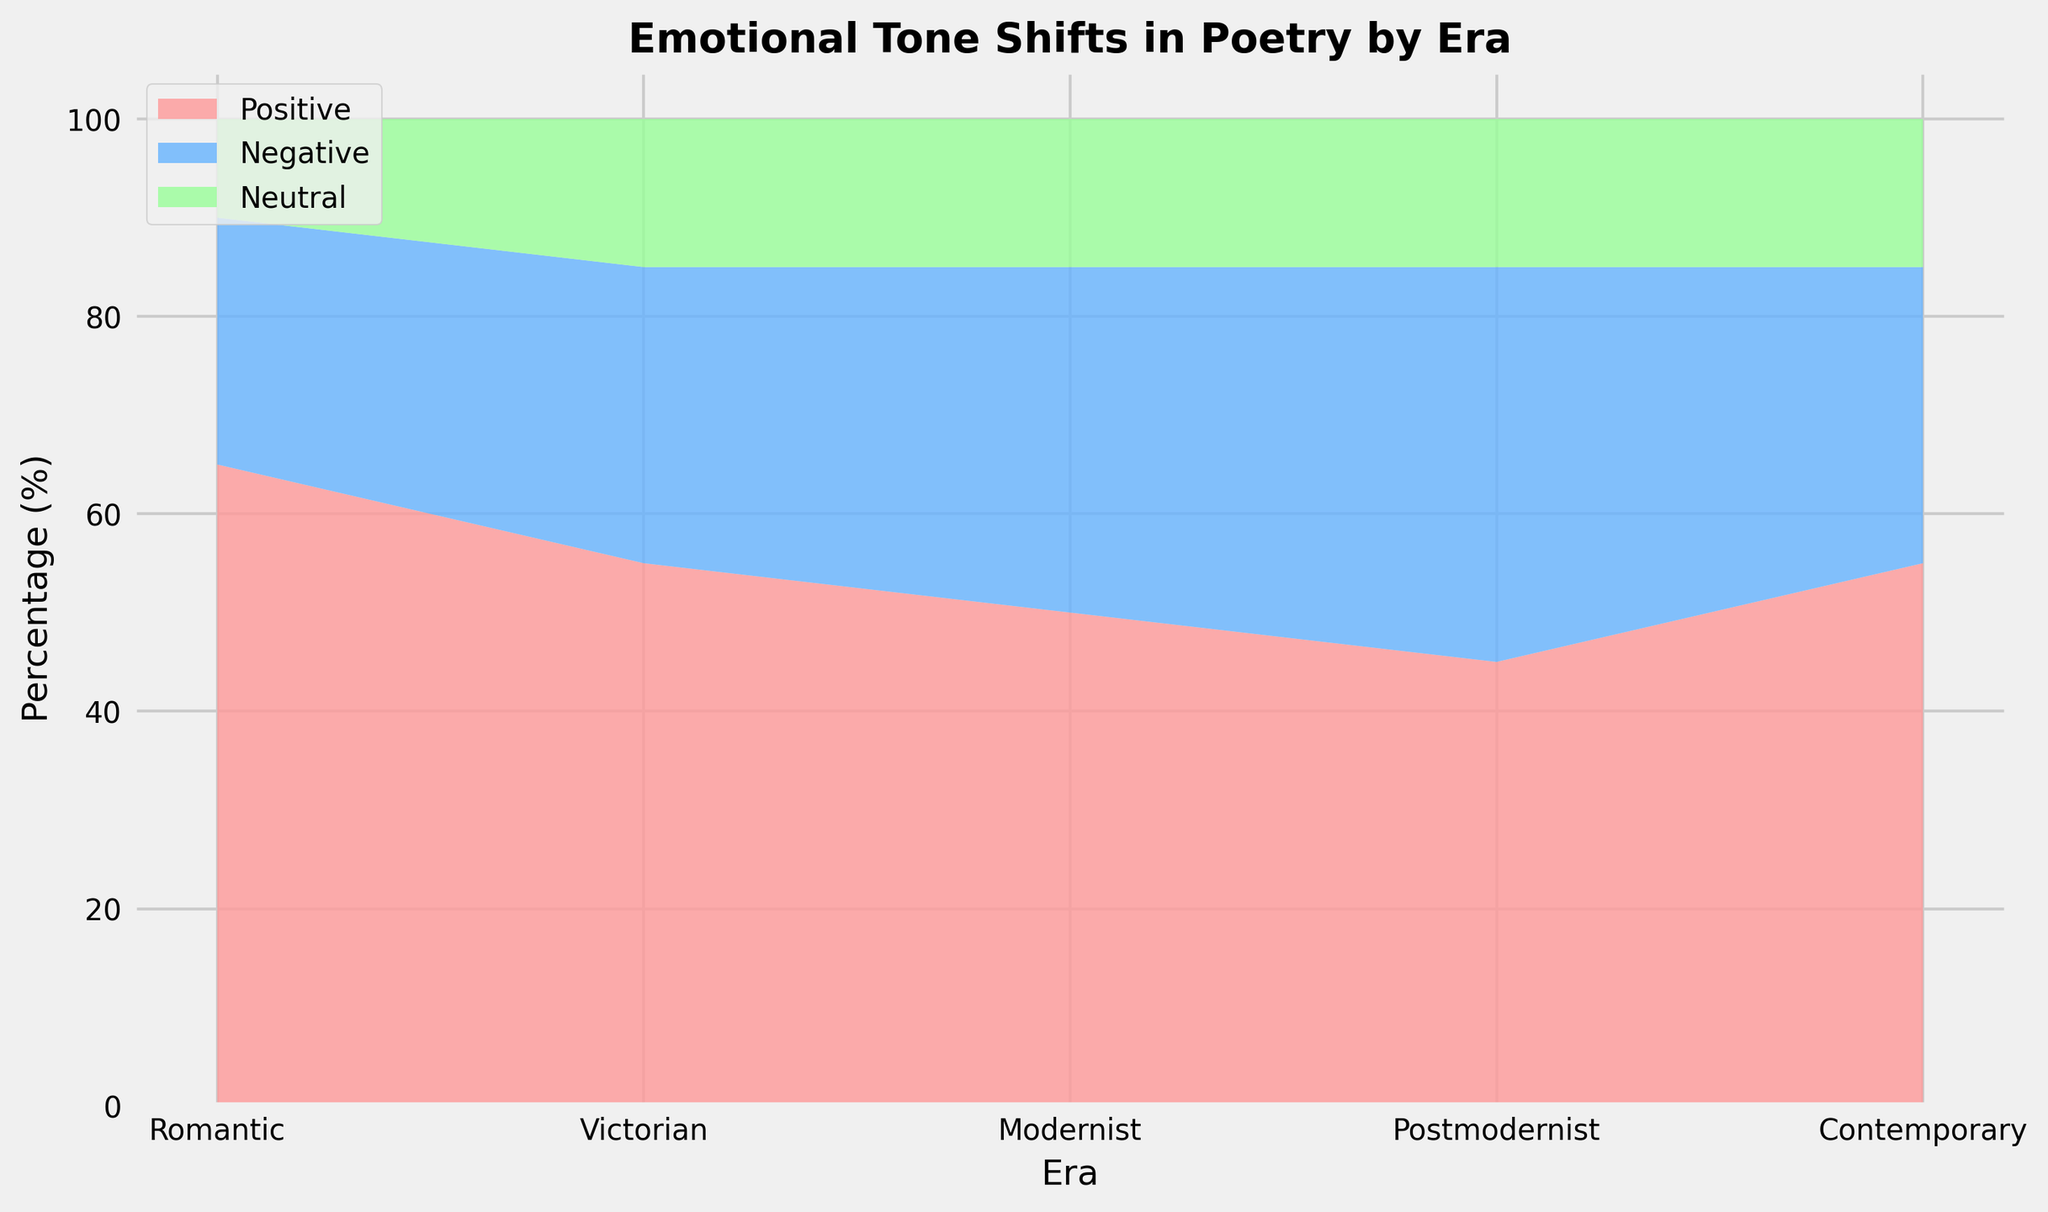What are the proportions of positive, negative, and neutral tones in the Victorian era? The Victorian era in the figure shows three areas: red for positive, blue for negative, and green for neutral. The proportions are given as 55% positive, 30% negative, and 15% neutral.
Answer: Positive: 55%, Negative: 30%, Neutral: 15% Which era shows the highest proportion of negative tones? The figure indicates different proportions of tones for each era. The Postmodernist era's negative tone area is the largest, indicating that it has the highest proportion at 40%.
Answer: Postmodernist How do the proportions of neutral tones change from the Romantic to the Modernist era? From the Romantic era to the Modernist era, the neutral tone proportion starts at 10%, increases to 15% in the Victorian era, and remains at 15% in the Modernist era. There is an increase from 10% to 15% between Romantic and Victorian eras but remains consistent from Victorian to Modernist.
Answer: Increased from 10% to 15%, then remained at 15% Compare the proportions of positive tones in the Romantic and Contemporary eras. Which one is higher and by how much? The figure shows that the Romantic era has 65% positive tones while the Contemporary era has 55%. The Romantic era thus has a higher proportion of positive tones by 10%.
Answer: Romantic by 10% How does the total proportion of non-neutral tones in the Contemporary era compare to that in the Victorian era? Adding the proportions of positive and negative tones: Victorian era has 55% positive + 30% negative = 85%, and the Contemporary era has 55% positive + 30% negative = 85%. Therefore, the total proportions are equal.
Answer: Equal, both are 85% Which era has the smallest variation in the proportions of emotional tones? The Victorian, Modernist, Postmodernist, and Contemporary eras all exhibit similar variation in emotional tones, with differences not exceeding 25%. The Romantic era shows a more significant variation, especially with a 65% positive tone. Therefore, the smallest variation is found in the eras other than Romantic. Inspecting visually, the eras besides Romantic exhibit this, but a closer look at percentages confirms Victorian is one of those.
Answer: Victorian, Modernist, Postmodernist, Contemporary all have smallest variations; detailed indication shows Victorian and others close Calculate the average proportion of positive tones across all eras. The proportions of positive tones are 65%, 55%, 50%, 45%, and 55%. Summing them up: 65 + 55 + 50 + 45 + 55 = 270. Dividing by 5 eras gives the average: 270 / 5 = 54%.
Answer: 54% Which era experienced the greatest drop in positive tones compared to its predecessor? The figure shows a drop in positive tones between eras. From Romantic (65%) to Victorian (55%) is a 10% drop. From Victorian (55%) to Modernist (50%) is a 5% drop. From Modernist (50%) to Postmodernist (45%) is also a 5% drop. The highest is 10%, between Romantic and Victorian eras.
Answer: Victorian from Romantic by 10% What is the cumulative area size for neutral tones from Romantic to Contemporary eras? (Assume each era covers equal visual width.) The neutral tones are given as 10%, 15%, 15%, 15% and 15% across the eras from Romantic to Contemporary. Adding these: 10 + 15 + 15 + 15 + 15 = 70%.
Answer: 70% Which colors in the figure represent the positive, negative, and neutral tones? The figure uses distinct colors to represent different tones: red for positive, blue for negative, and green for neutral.
Answer: Positive: Red, Negative: Blue, Neutral: Green 